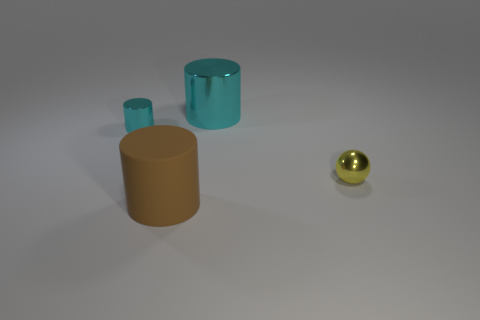Subtract all gray cylinders. Subtract all yellow spheres. How many cylinders are left? 3 Add 4 large green cylinders. How many objects exist? 8 Subtract all cylinders. How many objects are left? 1 Add 3 tiny yellow metal objects. How many tiny yellow metal objects exist? 4 Subtract 0 gray cylinders. How many objects are left? 4 Subtract all big matte cylinders. Subtract all yellow metal balls. How many objects are left? 2 Add 2 big rubber things. How many big rubber things are left? 3 